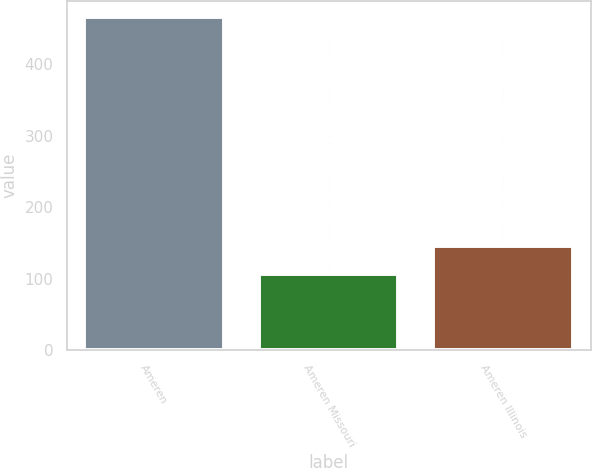Convert chart. <chart><loc_0><loc_0><loc_500><loc_500><bar_chart><fcel>Ameren<fcel>Ameren Missouri<fcel>Ameren Illinois<nl><fcel>466<fcel>107<fcel>146<nl></chart> 